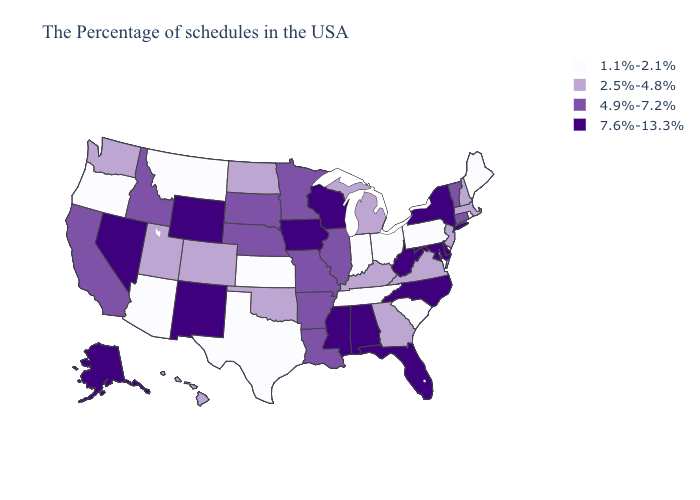Name the states that have a value in the range 7.6%-13.3%?
Give a very brief answer. New York, Delaware, Maryland, North Carolina, West Virginia, Florida, Alabama, Wisconsin, Mississippi, Iowa, Wyoming, New Mexico, Nevada, Alaska. Does the first symbol in the legend represent the smallest category?
Answer briefly. Yes. What is the lowest value in the Northeast?
Give a very brief answer. 1.1%-2.1%. Among the states that border Michigan , which have the highest value?
Answer briefly. Wisconsin. What is the value of Pennsylvania?
Answer briefly. 1.1%-2.1%. Does Washington have the lowest value in the USA?
Quick response, please. No. Does the first symbol in the legend represent the smallest category?
Write a very short answer. Yes. What is the value of Connecticut?
Concise answer only. 4.9%-7.2%. Does the map have missing data?
Concise answer only. No. Does Ohio have the lowest value in the USA?
Answer briefly. Yes. Does California have the lowest value in the USA?
Short answer required. No. What is the value of Alaska?
Keep it brief. 7.6%-13.3%. What is the highest value in states that border Wisconsin?
Short answer required. 7.6%-13.3%. What is the highest value in the USA?
Quick response, please. 7.6%-13.3%. Does Virginia have the lowest value in the South?
Write a very short answer. No. 